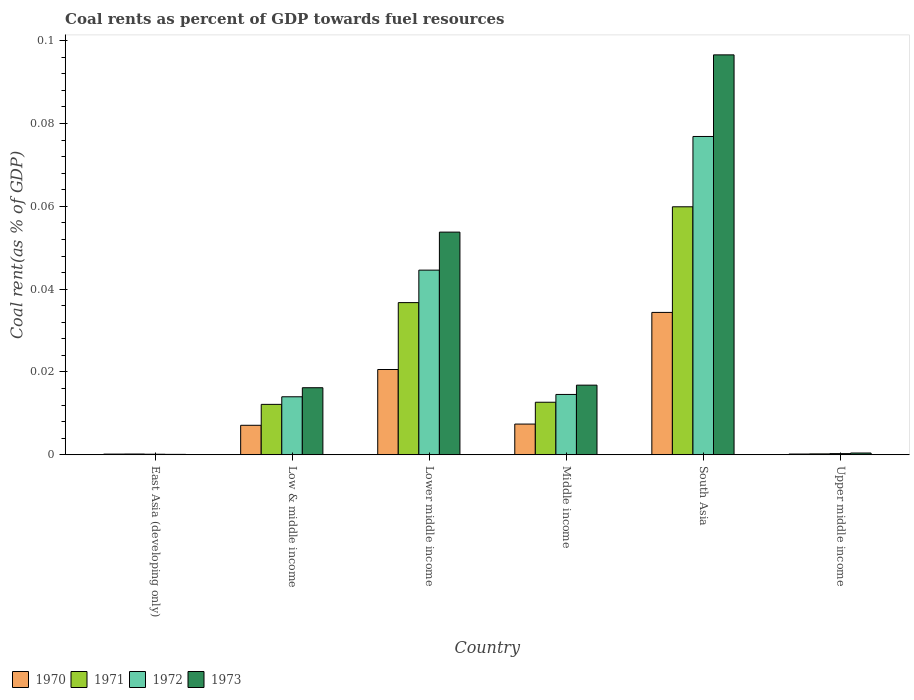How many groups of bars are there?
Provide a short and direct response. 6. Are the number of bars on each tick of the X-axis equal?
Your answer should be very brief. Yes. How many bars are there on the 6th tick from the left?
Your response must be concise. 4. What is the label of the 6th group of bars from the left?
Ensure brevity in your answer.  Upper middle income. What is the coal rent in 1972 in Middle income?
Keep it short and to the point. 0.01. Across all countries, what is the maximum coal rent in 1973?
Provide a short and direct response. 0.1. Across all countries, what is the minimum coal rent in 1970?
Provide a succinct answer. 0. In which country was the coal rent in 1972 minimum?
Your answer should be very brief. East Asia (developing only). What is the total coal rent in 1970 in the graph?
Provide a short and direct response. 0.07. What is the difference between the coal rent in 1973 in Low & middle income and that in Upper middle income?
Ensure brevity in your answer.  0.02. What is the difference between the coal rent in 1972 in Low & middle income and the coal rent in 1973 in Upper middle income?
Ensure brevity in your answer.  0.01. What is the average coal rent in 1971 per country?
Offer a very short reply. 0.02. What is the difference between the coal rent of/in 1970 and coal rent of/in 1971 in Middle income?
Give a very brief answer. -0.01. What is the ratio of the coal rent in 1973 in East Asia (developing only) to that in Lower middle income?
Provide a succinct answer. 0. Is the difference between the coal rent in 1970 in East Asia (developing only) and Upper middle income greater than the difference between the coal rent in 1971 in East Asia (developing only) and Upper middle income?
Make the answer very short. Yes. What is the difference between the highest and the second highest coal rent in 1973?
Make the answer very short. 0.08. What is the difference between the highest and the lowest coal rent in 1972?
Provide a succinct answer. 0.08. What does the 3rd bar from the left in Lower middle income represents?
Keep it short and to the point. 1972. What does the 3rd bar from the right in South Asia represents?
Offer a very short reply. 1971. Is it the case that in every country, the sum of the coal rent in 1972 and coal rent in 1971 is greater than the coal rent in 1970?
Keep it short and to the point. Yes. How many countries are there in the graph?
Your answer should be compact. 6. Are the values on the major ticks of Y-axis written in scientific E-notation?
Make the answer very short. No. Does the graph contain grids?
Keep it short and to the point. No. Where does the legend appear in the graph?
Offer a very short reply. Bottom left. How many legend labels are there?
Offer a very short reply. 4. How are the legend labels stacked?
Provide a short and direct response. Horizontal. What is the title of the graph?
Provide a short and direct response. Coal rents as percent of GDP towards fuel resources. Does "2004" appear as one of the legend labels in the graph?
Make the answer very short. No. What is the label or title of the X-axis?
Offer a very short reply. Country. What is the label or title of the Y-axis?
Your answer should be compact. Coal rent(as % of GDP). What is the Coal rent(as % of GDP) in 1970 in East Asia (developing only)?
Offer a terse response. 0. What is the Coal rent(as % of GDP) in 1971 in East Asia (developing only)?
Offer a very short reply. 0. What is the Coal rent(as % of GDP) of 1972 in East Asia (developing only)?
Keep it short and to the point. 0. What is the Coal rent(as % of GDP) of 1973 in East Asia (developing only)?
Your answer should be very brief. 0. What is the Coal rent(as % of GDP) of 1970 in Low & middle income?
Make the answer very short. 0.01. What is the Coal rent(as % of GDP) of 1971 in Low & middle income?
Make the answer very short. 0.01. What is the Coal rent(as % of GDP) of 1972 in Low & middle income?
Provide a short and direct response. 0.01. What is the Coal rent(as % of GDP) in 1973 in Low & middle income?
Offer a terse response. 0.02. What is the Coal rent(as % of GDP) of 1970 in Lower middle income?
Provide a succinct answer. 0.02. What is the Coal rent(as % of GDP) in 1971 in Lower middle income?
Give a very brief answer. 0.04. What is the Coal rent(as % of GDP) in 1972 in Lower middle income?
Give a very brief answer. 0.04. What is the Coal rent(as % of GDP) in 1973 in Lower middle income?
Provide a short and direct response. 0.05. What is the Coal rent(as % of GDP) of 1970 in Middle income?
Offer a terse response. 0.01. What is the Coal rent(as % of GDP) of 1971 in Middle income?
Offer a very short reply. 0.01. What is the Coal rent(as % of GDP) in 1972 in Middle income?
Make the answer very short. 0.01. What is the Coal rent(as % of GDP) of 1973 in Middle income?
Provide a succinct answer. 0.02. What is the Coal rent(as % of GDP) in 1970 in South Asia?
Offer a terse response. 0.03. What is the Coal rent(as % of GDP) of 1971 in South Asia?
Provide a succinct answer. 0.06. What is the Coal rent(as % of GDP) in 1972 in South Asia?
Your answer should be very brief. 0.08. What is the Coal rent(as % of GDP) in 1973 in South Asia?
Keep it short and to the point. 0.1. What is the Coal rent(as % of GDP) of 1970 in Upper middle income?
Your answer should be very brief. 0. What is the Coal rent(as % of GDP) of 1971 in Upper middle income?
Your response must be concise. 0. What is the Coal rent(as % of GDP) in 1972 in Upper middle income?
Provide a short and direct response. 0. What is the Coal rent(as % of GDP) in 1973 in Upper middle income?
Offer a terse response. 0. Across all countries, what is the maximum Coal rent(as % of GDP) of 1970?
Make the answer very short. 0.03. Across all countries, what is the maximum Coal rent(as % of GDP) of 1971?
Your answer should be compact. 0.06. Across all countries, what is the maximum Coal rent(as % of GDP) in 1972?
Provide a short and direct response. 0.08. Across all countries, what is the maximum Coal rent(as % of GDP) in 1973?
Keep it short and to the point. 0.1. Across all countries, what is the minimum Coal rent(as % of GDP) in 1970?
Provide a short and direct response. 0. Across all countries, what is the minimum Coal rent(as % of GDP) of 1971?
Your answer should be very brief. 0. Across all countries, what is the minimum Coal rent(as % of GDP) of 1972?
Your answer should be compact. 0. Across all countries, what is the minimum Coal rent(as % of GDP) in 1973?
Give a very brief answer. 0. What is the total Coal rent(as % of GDP) in 1970 in the graph?
Offer a terse response. 0.07. What is the total Coal rent(as % of GDP) in 1971 in the graph?
Your answer should be very brief. 0.12. What is the total Coal rent(as % of GDP) of 1972 in the graph?
Your answer should be compact. 0.15. What is the total Coal rent(as % of GDP) in 1973 in the graph?
Your answer should be very brief. 0.18. What is the difference between the Coal rent(as % of GDP) in 1970 in East Asia (developing only) and that in Low & middle income?
Your answer should be compact. -0.01. What is the difference between the Coal rent(as % of GDP) of 1971 in East Asia (developing only) and that in Low & middle income?
Keep it short and to the point. -0.01. What is the difference between the Coal rent(as % of GDP) in 1972 in East Asia (developing only) and that in Low & middle income?
Make the answer very short. -0.01. What is the difference between the Coal rent(as % of GDP) in 1973 in East Asia (developing only) and that in Low & middle income?
Provide a succinct answer. -0.02. What is the difference between the Coal rent(as % of GDP) of 1970 in East Asia (developing only) and that in Lower middle income?
Provide a short and direct response. -0.02. What is the difference between the Coal rent(as % of GDP) in 1971 in East Asia (developing only) and that in Lower middle income?
Provide a succinct answer. -0.04. What is the difference between the Coal rent(as % of GDP) in 1972 in East Asia (developing only) and that in Lower middle income?
Make the answer very short. -0.04. What is the difference between the Coal rent(as % of GDP) of 1973 in East Asia (developing only) and that in Lower middle income?
Keep it short and to the point. -0.05. What is the difference between the Coal rent(as % of GDP) in 1970 in East Asia (developing only) and that in Middle income?
Provide a short and direct response. -0.01. What is the difference between the Coal rent(as % of GDP) of 1971 in East Asia (developing only) and that in Middle income?
Keep it short and to the point. -0.01. What is the difference between the Coal rent(as % of GDP) of 1972 in East Asia (developing only) and that in Middle income?
Your response must be concise. -0.01. What is the difference between the Coal rent(as % of GDP) in 1973 in East Asia (developing only) and that in Middle income?
Keep it short and to the point. -0.02. What is the difference between the Coal rent(as % of GDP) in 1970 in East Asia (developing only) and that in South Asia?
Your response must be concise. -0.03. What is the difference between the Coal rent(as % of GDP) of 1971 in East Asia (developing only) and that in South Asia?
Provide a short and direct response. -0.06. What is the difference between the Coal rent(as % of GDP) in 1972 in East Asia (developing only) and that in South Asia?
Keep it short and to the point. -0.08. What is the difference between the Coal rent(as % of GDP) in 1973 in East Asia (developing only) and that in South Asia?
Ensure brevity in your answer.  -0.1. What is the difference between the Coal rent(as % of GDP) in 1971 in East Asia (developing only) and that in Upper middle income?
Keep it short and to the point. -0. What is the difference between the Coal rent(as % of GDP) in 1972 in East Asia (developing only) and that in Upper middle income?
Keep it short and to the point. -0. What is the difference between the Coal rent(as % of GDP) in 1973 in East Asia (developing only) and that in Upper middle income?
Make the answer very short. -0. What is the difference between the Coal rent(as % of GDP) of 1970 in Low & middle income and that in Lower middle income?
Your response must be concise. -0.01. What is the difference between the Coal rent(as % of GDP) in 1971 in Low & middle income and that in Lower middle income?
Make the answer very short. -0.02. What is the difference between the Coal rent(as % of GDP) of 1972 in Low & middle income and that in Lower middle income?
Make the answer very short. -0.03. What is the difference between the Coal rent(as % of GDP) in 1973 in Low & middle income and that in Lower middle income?
Offer a terse response. -0.04. What is the difference between the Coal rent(as % of GDP) in 1970 in Low & middle income and that in Middle income?
Provide a short and direct response. -0. What is the difference between the Coal rent(as % of GDP) in 1971 in Low & middle income and that in Middle income?
Your response must be concise. -0. What is the difference between the Coal rent(as % of GDP) in 1972 in Low & middle income and that in Middle income?
Make the answer very short. -0. What is the difference between the Coal rent(as % of GDP) in 1973 in Low & middle income and that in Middle income?
Give a very brief answer. -0. What is the difference between the Coal rent(as % of GDP) of 1970 in Low & middle income and that in South Asia?
Your response must be concise. -0.03. What is the difference between the Coal rent(as % of GDP) of 1971 in Low & middle income and that in South Asia?
Provide a short and direct response. -0.05. What is the difference between the Coal rent(as % of GDP) in 1972 in Low & middle income and that in South Asia?
Provide a short and direct response. -0.06. What is the difference between the Coal rent(as % of GDP) of 1973 in Low & middle income and that in South Asia?
Ensure brevity in your answer.  -0.08. What is the difference between the Coal rent(as % of GDP) of 1970 in Low & middle income and that in Upper middle income?
Provide a short and direct response. 0.01. What is the difference between the Coal rent(as % of GDP) of 1971 in Low & middle income and that in Upper middle income?
Keep it short and to the point. 0.01. What is the difference between the Coal rent(as % of GDP) in 1972 in Low & middle income and that in Upper middle income?
Provide a short and direct response. 0.01. What is the difference between the Coal rent(as % of GDP) of 1973 in Low & middle income and that in Upper middle income?
Your answer should be compact. 0.02. What is the difference between the Coal rent(as % of GDP) in 1970 in Lower middle income and that in Middle income?
Make the answer very short. 0.01. What is the difference between the Coal rent(as % of GDP) of 1971 in Lower middle income and that in Middle income?
Provide a succinct answer. 0.02. What is the difference between the Coal rent(as % of GDP) of 1973 in Lower middle income and that in Middle income?
Your answer should be very brief. 0.04. What is the difference between the Coal rent(as % of GDP) in 1970 in Lower middle income and that in South Asia?
Provide a short and direct response. -0.01. What is the difference between the Coal rent(as % of GDP) of 1971 in Lower middle income and that in South Asia?
Provide a short and direct response. -0.02. What is the difference between the Coal rent(as % of GDP) in 1972 in Lower middle income and that in South Asia?
Offer a very short reply. -0.03. What is the difference between the Coal rent(as % of GDP) of 1973 in Lower middle income and that in South Asia?
Give a very brief answer. -0.04. What is the difference between the Coal rent(as % of GDP) of 1970 in Lower middle income and that in Upper middle income?
Give a very brief answer. 0.02. What is the difference between the Coal rent(as % of GDP) in 1971 in Lower middle income and that in Upper middle income?
Provide a short and direct response. 0.04. What is the difference between the Coal rent(as % of GDP) in 1972 in Lower middle income and that in Upper middle income?
Offer a terse response. 0.04. What is the difference between the Coal rent(as % of GDP) in 1973 in Lower middle income and that in Upper middle income?
Provide a succinct answer. 0.05. What is the difference between the Coal rent(as % of GDP) in 1970 in Middle income and that in South Asia?
Make the answer very short. -0.03. What is the difference between the Coal rent(as % of GDP) of 1971 in Middle income and that in South Asia?
Ensure brevity in your answer.  -0.05. What is the difference between the Coal rent(as % of GDP) in 1972 in Middle income and that in South Asia?
Provide a succinct answer. -0.06. What is the difference between the Coal rent(as % of GDP) of 1973 in Middle income and that in South Asia?
Give a very brief answer. -0.08. What is the difference between the Coal rent(as % of GDP) of 1970 in Middle income and that in Upper middle income?
Keep it short and to the point. 0.01. What is the difference between the Coal rent(as % of GDP) in 1971 in Middle income and that in Upper middle income?
Your answer should be very brief. 0.01. What is the difference between the Coal rent(as % of GDP) of 1972 in Middle income and that in Upper middle income?
Your answer should be compact. 0.01. What is the difference between the Coal rent(as % of GDP) in 1973 in Middle income and that in Upper middle income?
Offer a very short reply. 0.02. What is the difference between the Coal rent(as % of GDP) of 1970 in South Asia and that in Upper middle income?
Keep it short and to the point. 0.03. What is the difference between the Coal rent(as % of GDP) of 1971 in South Asia and that in Upper middle income?
Your response must be concise. 0.06. What is the difference between the Coal rent(as % of GDP) in 1972 in South Asia and that in Upper middle income?
Keep it short and to the point. 0.08. What is the difference between the Coal rent(as % of GDP) in 1973 in South Asia and that in Upper middle income?
Ensure brevity in your answer.  0.1. What is the difference between the Coal rent(as % of GDP) of 1970 in East Asia (developing only) and the Coal rent(as % of GDP) of 1971 in Low & middle income?
Provide a succinct answer. -0.01. What is the difference between the Coal rent(as % of GDP) of 1970 in East Asia (developing only) and the Coal rent(as % of GDP) of 1972 in Low & middle income?
Offer a terse response. -0.01. What is the difference between the Coal rent(as % of GDP) in 1970 in East Asia (developing only) and the Coal rent(as % of GDP) in 1973 in Low & middle income?
Give a very brief answer. -0.02. What is the difference between the Coal rent(as % of GDP) of 1971 in East Asia (developing only) and the Coal rent(as % of GDP) of 1972 in Low & middle income?
Offer a terse response. -0.01. What is the difference between the Coal rent(as % of GDP) in 1971 in East Asia (developing only) and the Coal rent(as % of GDP) in 1973 in Low & middle income?
Your answer should be compact. -0.02. What is the difference between the Coal rent(as % of GDP) of 1972 in East Asia (developing only) and the Coal rent(as % of GDP) of 1973 in Low & middle income?
Offer a very short reply. -0.02. What is the difference between the Coal rent(as % of GDP) of 1970 in East Asia (developing only) and the Coal rent(as % of GDP) of 1971 in Lower middle income?
Keep it short and to the point. -0.04. What is the difference between the Coal rent(as % of GDP) in 1970 in East Asia (developing only) and the Coal rent(as % of GDP) in 1972 in Lower middle income?
Offer a terse response. -0.04. What is the difference between the Coal rent(as % of GDP) of 1970 in East Asia (developing only) and the Coal rent(as % of GDP) of 1973 in Lower middle income?
Make the answer very short. -0.05. What is the difference between the Coal rent(as % of GDP) in 1971 in East Asia (developing only) and the Coal rent(as % of GDP) in 1972 in Lower middle income?
Offer a very short reply. -0.04. What is the difference between the Coal rent(as % of GDP) in 1971 in East Asia (developing only) and the Coal rent(as % of GDP) in 1973 in Lower middle income?
Offer a very short reply. -0.05. What is the difference between the Coal rent(as % of GDP) of 1972 in East Asia (developing only) and the Coal rent(as % of GDP) of 1973 in Lower middle income?
Provide a succinct answer. -0.05. What is the difference between the Coal rent(as % of GDP) in 1970 in East Asia (developing only) and the Coal rent(as % of GDP) in 1971 in Middle income?
Keep it short and to the point. -0.01. What is the difference between the Coal rent(as % of GDP) in 1970 in East Asia (developing only) and the Coal rent(as % of GDP) in 1972 in Middle income?
Offer a very short reply. -0.01. What is the difference between the Coal rent(as % of GDP) of 1970 in East Asia (developing only) and the Coal rent(as % of GDP) of 1973 in Middle income?
Offer a terse response. -0.02. What is the difference between the Coal rent(as % of GDP) in 1971 in East Asia (developing only) and the Coal rent(as % of GDP) in 1972 in Middle income?
Make the answer very short. -0.01. What is the difference between the Coal rent(as % of GDP) in 1971 in East Asia (developing only) and the Coal rent(as % of GDP) in 1973 in Middle income?
Keep it short and to the point. -0.02. What is the difference between the Coal rent(as % of GDP) of 1972 in East Asia (developing only) and the Coal rent(as % of GDP) of 1973 in Middle income?
Your answer should be compact. -0.02. What is the difference between the Coal rent(as % of GDP) of 1970 in East Asia (developing only) and the Coal rent(as % of GDP) of 1971 in South Asia?
Offer a very short reply. -0.06. What is the difference between the Coal rent(as % of GDP) in 1970 in East Asia (developing only) and the Coal rent(as % of GDP) in 1972 in South Asia?
Provide a short and direct response. -0.08. What is the difference between the Coal rent(as % of GDP) of 1970 in East Asia (developing only) and the Coal rent(as % of GDP) of 1973 in South Asia?
Your response must be concise. -0.1. What is the difference between the Coal rent(as % of GDP) in 1971 in East Asia (developing only) and the Coal rent(as % of GDP) in 1972 in South Asia?
Make the answer very short. -0.08. What is the difference between the Coal rent(as % of GDP) of 1971 in East Asia (developing only) and the Coal rent(as % of GDP) of 1973 in South Asia?
Make the answer very short. -0.1. What is the difference between the Coal rent(as % of GDP) of 1972 in East Asia (developing only) and the Coal rent(as % of GDP) of 1973 in South Asia?
Provide a succinct answer. -0.1. What is the difference between the Coal rent(as % of GDP) in 1970 in East Asia (developing only) and the Coal rent(as % of GDP) in 1971 in Upper middle income?
Your answer should be very brief. -0. What is the difference between the Coal rent(as % of GDP) in 1970 in East Asia (developing only) and the Coal rent(as % of GDP) in 1972 in Upper middle income?
Your response must be concise. -0. What is the difference between the Coal rent(as % of GDP) in 1970 in East Asia (developing only) and the Coal rent(as % of GDP) in 1973 in Upper middle income?
Your answer should be very brief. -0. What is the difference between the Coal rent(as % of GDP) of 1971 in East Asia (developing only) and the Coal rent(as % of GDP) of 1972 in Upper middle income?
Your response must be concise. -0. What is the difference between the Coal rent(as % of GDP) of 1971 in East Asia (developing only) and the Coal rent(as % of GDP) of 1973 in Upper middle income?
Your response must be concise. -0. What is the difference between the Coal rent(as % of GDP) in 1972 in East Asia (developing only) and the Coal rent(as % of GDP) in 1973 in Upper middle income?
Offer a very short reply. -0. What is the difference between the Coal rent(as % of GDP) in 1970 in Low & middle income and the Coal rent(as % of GDP) in 1971 in Lower middle income?
Offer a terse response. -0.03. What is the difference between the Coal rent(as % of GDP) in 1970 in Low & middle income and the Coal rent(as % of GDP) in 1972 in Lower middle income?
Offer a very short reply. -0.04. What is the difference between the Coal rent(as % of GDP) of 1970 in Low & middle income and the Coal rent(as % of GDP) of 1973 in Lower middle income?
Keep it short and to the point. -0.05. What is the difference between the Coal rent(as % of GDP) of 1971 in Low & middle income and the Coal rent(as % of GDP) of 1972 in Lower middle income?
Your answer should be very brief. -0.03. What is the difference between the Coal rent(as % of GDP) of 1971 in Low & middle income and the Coal rent(as % of GDP) of 1973 in Lower middle income?
Your answer should be very brief. -0.04. What is the difference between the Coal rent(as % of GDP) in 1972 in Low & middle income and the Coal rent(as % of GDP) in 1973 in Lower middle income?
Provide a succinct answer. -0.04. What is the difference between the Coal rent(as % of GDP) of 1970 in Low & middle income and the Coal rent(as % of GDP) of 1971 in Middle income?
Your answer should be very brief. -0.01. What is the difference between the Coal rent(as % of GDP) of 1970 in Low & middle income and the Coal rent(as % of GDP) of 1972 in Middle income?
Offer a terse response. -0.01. What is the difference between the Coal rent(as % of GDP) of 1970 in Low & middle income and the Coal rent(as % of GDP) of 1973 in Middle income?
Provide a succinct answer. -0.01. What is the difference between the Coal rent(as % of GDP) of 1971 in Low & middle income and the Coal rent(as % of GDP) of 1972 in Middle income?
Your response must be concise. -0. What is the difference between the Coal rent(as % of GDP) in 1971 in Low & middle income and the Coal rent(as % of GDP) in 1973 in Middle income?
Make the answer very short. -0. What is the difference between the Coal rent(as % of GDP) in 1972 in Low & middle income and the Coal rent(as % of GDP) in 1973 in Middle income?
Your answer should be very brief. -0. What is the difference between the Coal rent(as % of GDP) of 1970 in Low & middle income and the Coal rent(as % of GDP) of 1971 in South Asia?
Offer a very short reply. -0.05. What is the difference between the Coal rent(as % of GDP) in 1970 in Low & middle income and the Coal rent(as % of GDP) in 1972 in South Asia?
Keep it short and to the point. -0.07. What is the difference between the Coal rent(as % of GDP) in 1970 in Low & middle income and the Coal rent(as % of GDP) in 1973 in South Asia?
Ensure brevity in your answer.  -0.09. What is the difference between the Coal rent(as % of GDP) of 1971 in Low & middle income and the Coal rent(as % of GDP) of 1972 in South Asia?
Your response must be concise. -0.06. What is the difference between the Coal rent(as % of GDP) of 1971 in Low & middle income and the Coal rent(as % of GDP) of 1973 in South Asia?
Offer a very short reply. -0.08. What is the difference between the Coal rent(as % of GDP) in 1972 in Low & middle income and the Coal rent(as % of GDP) in 1973 in South Asia?
Provide a succinct answer. -0.08. What is the difference between the Coal rent(as % of GDP) of 1970 in Low & middle income and the Coal rent(as % of GDP) of 1971 in Upper middle income?
Offer a terse response. 0.01. What is the difference between the Coal rent(as % of GDP) in 1970 in Low & middle income and the Coal rent(as % of GDP) in 1972 in Upper middle income?
Your answer should be very brief. 0.01. What is the difference between the Coal rent(as % of GDP) in 1970 in Low & middle income and the Coal rent(as % of GDP) in 1973 in Upper middle income?
Your answer should be compact. 0.01. What is the difference between the Coal rent(as % of GDP) in 1971 in Low & middle income and the Coal rent(as % of GDP) in 1972 in Upper middle income?
Ensure brevity in your answer.  0.01. What is the difference between the Coal rent(as % of GDP) in 1971 in Low & middle income and the Coal rent(as % of GDP) in 1973 in Upper middle income?
Your answer should be compact. 0.01. What is the difference between the Coal rent(as % of GDP) of 1972 in Low & middle income and the Coal rent(as % of GDP) of 1973 in Upper middle income?
Keep it short and to the point. 0.01. What is the difference between the Coal rent(as % of GDP) in 1970 in Lower middle income and the Coal rent(as % of GDP) in 1971 in Middle income?
Offer a very short reply. 0.01. What is the difference between the Coal rent(as % of GDP) of 1970 in Lower middle income and the Coal rent(as % of GDP) of 1972 in Middle income?
Give a very brief answer. 0.01. What is the difference between the Coal rent(as % of GDP) in 1970 in Lower middle income and the Coal rent(as % of GDP) in 1973 in Middle income?
Provide a succinct answer. 0. What is the difference between the Coal rent(as % of GDP) in 1971 in Lower middle income and the Coal rent(as % of GDP) in 1972 in Middle income?
Give a very brief answer. 0.02. What is the difference between the Coal rent(as % of GDP) in 1971 in Lower middle income and the Coal rent(as % of GDP) in 1973 in Middle income?
Provide a succinct answer. 0.02. What is the difference between the Coal rent(as % of GDP) in 1972 in Lower middle income and the Coal rent(as % of GDP) in 1973 in Middle income?
Provide a succinct answer. 0.03. What is the difference between the Coal rent(as % of GDP) of 1970 in Lower middle income and the Coal rent(as % of GDP) of 1971 in South Asia?
Provide a short and direct response. -0.04. What is the difference between the Coal rent(as % of GDP) in 1970 in Lower middle income and the Coal rent(as % of GDP) in 1972 in South Asia?
Your response must be concise. -0.06. What is the difference between the Coal rent(as % of GDP) of 1970 in Lower middle income and the Coal rent(as % of GDP) of 1973 in South Asia?
Make the answer very short. -0.08. What is the difference between the Coal rent(as % of GDP) in 1971 in Lower middle income and the Coal rent(as % of GDP) in 1972 in South Asia?
Ensure brevity in your answer.  -0.04. What is the difference between the Coal rent(as % of GDP) in 1971 in Lower middle income and the Coal rent(as % of GDP) in 1973 in South Asia?
Your response must be concise. -0.06. What is the difference between the Coal rent(as % of GDP) in 1972 in Lower middle income and the Coal rent(as % of GDP) in 1973 in South Asia?
Provide a short and direct response. -0.05. What is the difference between the Coal rent(as % of GDP) in 1970 in Lower middle income and the Coal rent(as % of GDP) in 1971 in Upper middle income?
Offer a very short reply. 0.02. What is the difference between the Coal rent(as % of GDP) of 1970 in Lower middle income and the Coal rent(as % of GDP) of 1972 in Upper middle income?
Your answer should be compact. 0.02. What is the difference between the Coal rent(as % of GDP) of 1970 in Lower middle income and the Coal rent(as % of GDP) of 1973 in Upper middle income?
Ensure brevity in your answer.  0.02. What is the difference between the Coal rent(as % of GDP) of 1971 in Lower middle income and the Coal rent(as % of GDP) of 1972 in Upper middle income?
Offer a very short reply. 0.04. What is the difference between the Coal rent(as % of GDP) in 1971 in Lower middle income and the Coal rent(as % of GDP) in 1973 in Upper middle income?
Keep it short and to the point. 0.04. What is the difference between the Coal rent(as % of GDP) in 1972 in Lower middle income and the Coal rent(as % of GDP) in 1973 in Upper middle income?
Your response must be concise. 0.04. What is the difference between the Coal rent(as % of GDP) of 1970 in Middle income and the Coal rent(as % of GDP) of 1971 in South Asia?
Give a very brief answer. -0.05. What is the difference between the Coal rent(as % of GDP) in 1970 in Middle income and the Coal rent(as % of GDP) in 1972 in South Asia?
Keep it short and to the point. -0.07. What is the difference between the Coal rent(as % of GDP) of 1970 in Middle income and the Coal rent(as % of GDP) of 1973 in South Asia?
Make the answer very short. -0.09. What is the difference between the Coal rent(as % of GDP) of 1971 in Middle income and the Coal rent(as % of GDP) of 1972 in South Asia?
Make the answer very short. -0.06. What is the difference between the Coal rent(as % of GDP) in 1971 in Middle income and the Coal rent(as % of GDP) in 1973 in South Asia?
Your response must be concise. -0.08. What is the difference between the Coal rent(as % of GDP) of 1972 in Middle income and the Coal rent(as % of GDP) of 1973 in South Asia?
Give a very brief answer. -0.08. What is the difference between the Coal rent(as % of GDP) of 1970 in Middle income and the Coal rent(as % of GDP) of 1971 in Upper middle income?
Keep it short and to the point. 0.01. What is the difference between the Coal rent(as % of GDP) of 1970 in Middle income and the Coal rent(as % of GDP) of 1972 in Upper middle income?
Make the answer very short. 0.01. What is the difference between the Coal rent(as % of GDP) in 1970 in Middle income and the Coal rent(as % of GDP) in 1973 in Upper middle income?
Provide a succinct answer. 0.01. What is the difference between the Coal rent(as % of GDP) of 1971 in Middle income and the Coal rent(as % of GDP) of 1972 in Upper middle income?
Make the answer very short. 0.01. What is the difference between the Coal rent(as % of GDP) of 1971 in Middle income and the Coal rent(as % of GDP) of 1973 in Upper middle income?
Ensure brevity in your answer.  0.01. What is the difference between the Coal rent(as % of GDP) of 1972 in Middle income and the Coal rent(as % of GDP) of 1973 in Upper middle income?
Your answer should be compact. 0.01. What is the difference between the Coal rent(as % of GDP) of 1970 in South Asia and the Coal rent(as % of GDP) of 1971 in Upper middle income?
Provide a short and direct response. 0.03. What is the difference between the Coal rent(as % of GDP) in 1970 in South Asia and the Coal rent(as % of GDP) in 1972 in Upper middle income?
Your response must be concise. 0.03. What is the difference between the Coal rent(as % of GDP) of 1970 in South Asia and the Coal rent(as % of GDP) of 1973 in Upper middle income?
Keep it short and to the point. 0.03. What is the difference between the Coal rent(as % of GDP) of 1971 in South Asia and the Coal rent(as % of GDP) of 1972 in Upper middle income?
Provide a succinct answer. 0.06. What is the difference between the Coal rent(as % of GDP) of 1971 in South Asia and the Coal rent(as % of GDP) of 1973 in Upper middle income?
Offer a very short reply. 0.06. What is the difference between the Coal rent(as % of GDP) in 1972 in South Asia and the Coal rent(as % of GDP) in 1973 in Upper middle income?
Keep it short and to the point. 0.08. What is the average Coal rent(as % of GDP) in 1970 per country?
Your answer should be very brief. 0.01. What is the average Coal rent(as % of GDP) in 1971 per country?
Provide a short and direct response. 0.02. What is the average Coal rent(as % of GDP) in 1972 per country?
Ensure brevity in your answer.  0.03. What is the average Coal rent(as % of GDP) of 1973 per country?
Keep it short and to the point. 0.03. What is the difference between the Coal rent(as % of GDP) in 1970 and Coal rent(as % of GDP) in 1971 in East Asia (developing only)?
Offer a terse response. -0. What is the difference between the Coal rent(as % of GDP) of 1970 and Coal rent(as % of GDP) of 1971 in Low & middle income?
Your response must be concise. -0.01. What is the difference between the Coal rent(as % of GDP) in 1970 and Coal rent(as % of GDP) in 1972 in Low & middle income?
Make the answer very short. -0.01. What is the difference between the Coal rent(as % of GDP) of 1970 and Coal rent(as % of GDP) of 1973 in Low & middle income?
Your answer should be compact. -0.01. What is the difference between the Coal rent(as % of GDP) of 1971 and Coal rent(as % of GDP) of 1972 in Low & middle income?
Provide a succinct answer. -0. What is the difference between the Coal rent(as % of GDP) in 1971 and Coal rent(as % of GDP) in 1973 in Low & middle income?
Your answer should be compact. -0. What is the difference between the Coal rent(as % of GDP) of 1972 and Coal rent(as % of GDP) of 1973 in Low & middle income?
Your answer should be compact. -0. What is the difference between the Coal rent(as % of GDP) in 1970 and Coal rent(as % of GDP) in 1971 in Lower middle income?
Offer a very short reply. -0.02. What is the difference between the Coal rent(as % of GDP) in 1970 and Coal rent(as % of GDP) in 1972 in Lower middle income?
Provide a short and direct response. -0.02. What is the difference between the Coal rent(as % of GDP) in 1970 and Coal rent(as % of GDP) in 1973 in Lower middle income?
Ensure brevity in your answer.  -0.03. What is the difference between the Coal rent(as % of GDP) of 1971 and Coal rent(as % of GDP) of 1972 in Lower middle income?
Make the answer very short. -0.01. What is the difference between the Coal rent(as % of GDP) of 1971 and Coal rent(as % of GDP) of 1973 in Lower middle income?
Offer a terse response. -0.02. What is the difference between the Coal rent(as % of GDP) in 1972 and Coal rent(as % of GDP) in 1973 in Lower middle income?
Provide a succinct answer. -0.01. What is the difference between the Coal rent(as % of GDP) of 1970 and Coal rent(as % of GDP) of 1971 in Middle income?
Give a very brief answer. -0.01. What is the difference between the Coal rent(as % of GDP) of 1970 and Coal rent(as % of GDP) of 1972 in Middle income?
Your response must be concise. -0.01. What is the difference between the Coal rent(as % of GDP) in 1970 and Coal rent(as % of GDP) in 1973 in Middle income?
Ensure brevity in your answer.  -0.01. What is the difference between the Coal rent(as % of GDP) in 1971 and Coal rent(as % of GDP) in 1972 in Middle income?
Your answer should be compact. -0. What is the difference between the Coal rent(as % of GDP) of 1971 and Coal rent(as % of GDP) of 1973 in Middle income?
Provide a succinct answer. -0. What is the difference between the Coal rent(as % of GDP) of 1972 and Coal rent(as % of GDP) of 1973 in Middle income?
Keep it short and to the point. -0. What is the difference between the Coal rent(as % of GDP) of 1970 and Coal rent(as % of GDP) of 1971 in South Asia?
Provide a succinct answer. -0.03. What is the difference between the Coal rent(as % of GDP) in 1970 and Coal rent(as % of GDP) in 1972 in South Asia?
Ensure brevity in your answer.  -0.04. What is the difference between the Coal rent(as % of GDP) in 1970 and Coal rent(as % of GDP) in 1973 in South Asia?
Provide a short and direct response. -0.06. What is the difference between the Coal rent(as % of GDP) of 1971 and Coal rent(as % of GDP) of 1972 in South Asia?
Give a very brief answer. -0.02. What is the difference between the Coal rent(as % of GDP) of 1971 and Coal rent(as % of GDP) of 1973 in South Asia?
Provide a short and direct response. -0.04. What is the difference between the Coal rent(as % of GDP) of 1972 and Coal rent(as % of GDP) of 1973 in South Asia?
Keep it short and to the point. -0.02. What is the difference between the Coal rent(as % of GDP) of 1970 and Coal rent(as % of GDP) of 1971 in Upper middle income?
Provide a succinct answer. -0. What is the difference between the Coal rent(as % of GDP) of 1970 and Coal rent(as % of GDP) of 1972 in Upper middle income?
Provide a succinct answer. -0. What is the difference between the Coal rent(as % of GDP) of 1970 and Coal rent(as % of GDP) of 1973 in Upper middle income?
Offer a very short reply. -0. What is the difference between the Coal rent(as % of GDP) in 1971 and Coal rent(as % of GDP) in 1972 in Upper middle income?
Offer a very short reply. -0. What is the difference between the Coal rent(as % of GDP) of 1971 and Coal rent(as % of GDP) of 1973 in Upper middle income?
Give a very brief answer. -0. What is the difference between the Coal rent(as % of GDP) of 1972 and Coal rent(as % of GDP) of 1973 in Upper middle income?
Keep it short and to the point. -0. What is the ratio of the Coal rent(as % of GDP) of 1970 in East Asia (developing only) to that in Low & middle income?
Ensure brevity in your answer.  0.02. What is the ratio of the Coal rent(as % of GDP) of 1971 in East Asia (developing only) to that in Low & middle income?
Offer a terse response. 0.02. What is the ratio of the Coal rent(as % of GDP) of 1972 in East Asia (developing only) to that in Low & middle income?
Your answer should be compact. 0.01. What is the ratio of the Coal rent(as % of GDP) in 1973 in East Asia (developing only) to that in Low & middle income?
Ensure brevity in your answer.  0.01. What is the ratio of the Coal rent(as % of GDP) in 1970 in East Asia (developing only) to that in Lower middle income?
Your response must be concise. 0.01. What is the ratio of the Coal rent(as % of GDP) of 1971 in East Asia (developing only) to that in Lower middle income?
Your answer should be very brief. 0.01. What is the ratio of the Coal rent(as % of GDP) in 1972 in East Asia (developing only) to that in Lower middle income?
Provide a short and direct response. 0. What is the ratio of the Coal rent(as % of GDP) in 1973 in East Asia (developing only) to that in Lower middle income?
Your response must be concise. 0. What is the ratio of the Coal rent(as % of GDP) in 1970 in East Asia (developing only) to that in Middle income?
Provide a short and direct response. 0.02. What is the ratio of the Coal rent(as % of GDP) in 1971 in East Asia (developing only) to that in Middle income?
Ensure brevity in your answer.  0.01. What is the ratio of the Coal rent(as % of GDP) in 1972 in East Asia (developing only) to that in Middle income?
Your answer should be compact. 0.01. What is the ratio of the Coal rent(as % of GDP) in 1973 in East Asia (developing only) to that in Middle income?
Offer a terse response. 0.01. What is the ratio of the Coal rent(as % of GDP) of 1970 in East Asia (developing only) to that in South Asia?
Your answer should be very brief. 0. What is the ratio of the Coal rent(as % of GDP) in 1971 in East Asia (developing only) to that in South Asia?
Give a very brief answer. 0. What is the ratio of the Coal rent(as % of GDP) in 1972 in East Asia (developing only) to that in South Asia?
Provide a short and direct response. 0. What is the ratio of the Coal rent(as % of GDP) in 1973 in East Asia (developing only) to that in South Asia?
Offer a very short reply. 0. What is the ratio of the Coal rent(as % of GDP) of 1970 in East Asia (developing only) to that in Upper middle income?
Provide a short and direct response. 0.91. What is the ratio of the Coal rent(as % of GDP) in 1971 in East Asia (developing only) to that in Upper middle income?
Your answer should be compact. 0.86. What is the ratio of the Coal rent(as % of GDP) of 1972 in East Asia (developing only) to that in Upper middle income?
Your response must be concise. 0.48. What is the ratio of the Coal rent(as % of GDP) in 1973 in East Asia (developing only) to that in Upper middle income?
Ensure brevity in your answer.  0.24. What is the ratio of the Coal rent(as % of GDP) in 1970 in Low & middle income to that in Lower middle income?
Your response must be concise. 0.35. What is the ratio of the Coal rent(as % of GDP) of 1971 in Low & middle income to that in Lower middle income?
Give a very brief answer. 0.33. What is the ratio of the Coal rent(as % of GDP) of 1972 in Low & middle income to that in Lower middle income?
Your answer should be very brief. 0.31. What is the ratio of the Coal rent(as % of GDP) in 1973 in Low & middle income to that in Lower middle income?
Offer a terse response. 0.3. What is the ratio of the Coal rent(as % of GDP) of 1970 in Low & middle income to that in Middle income?
Give a very brief answer. 0.96. What is the ratio of the Coal rent(as % of GDP) in 1971 in Low & middle income to that in Middle income?
Ensure brevity in your answer.  0.96. What is the ratio of the Coal rent(as % of GDP) of 1972 in Low & middle income to that in Middle income?
Your answer should be compact. 0.96. What is the ratio of the Coal rent(as % of GDP) in 1973 in Low & middle income to that in Middle income?
Offer a terse response. 0.96. What is the ratio of the Coal rent(as % of GDP) in 1970 in Low & middle income to that in South Asia?
Your answer should be very brief. 0.21. What is the ratio of the Coal rent(as % of GDP) of 1971 in Low & middle income to that in South Asia?
Give a very brief answer. 0.2. What is the ratio of the Coal rent(as % of GDP) of 1972 in Low & middle income to that in South Asia?
Offer a very short reply. 0.18. What is the ratio of the Coal rent(as % of GDP) in 1973 in Low & middle income to that in South Asia?
Your answer should be very brief. 0.17. What is the ratio of the Coal rent(as % of GDP) in 1970 in Low & middle income to that in Upper middle income?
Your response must be concise. 38.77. What is the ratio of the Coal rent(as % of GDP) in 1971 in Low & middle income to that in Upper middle income?
Keep it short and to the point. 55.66. What is the ratio of the Coal rent(as % of GDP) of 1972 in Low & middle income to that in Upper middle income?
Your response must be concise. 49.28. What is the ratio of the Coal rent(as % of GDP) of 1973 in Low & middle income to that in Upper middle income?
Ensure brevity in your answer.  37.59. What is the ratio of the Coal rent(as % of GDP) in 1970 in Lower middle income to that in Middle income?
Your answer should be compact. 2.78. What is the ratio of the Coal rent(as % of GDP) in 1971 in Lower middle income to that in Middle income?
Provide a short and direct response. 2.9. What is the ratio of the Coal rent(as % of GDP) in 1972 in Lower middle income to that in Middle income?
Offer a very short reply. 3.06. What is the ratio of the Coal rent(as % of GDP) in 1973 in Lower middle income to that in Middle income?
Your response must be concise. 3.2. What is the ratio of the Coal rent(as % of GDP) in 1970 in Lower middle income to that in South Asia?
Provide a succinct answer. 0.6. What is the ratio of the Coal rent(as % of GDP) in 1971 in Lower middle income to that in South Asia?
Ensure brevity in your answer.  0.61. What is the ratio of the Coal rent(as % of GDP) in 1972 in Lower middle income to that in South Asia?
Your answer should be very brief. 0.58. What is the ratio of the Coal rent(as % of GDP) in 1973 in Lower middle income to that in South Asia?
Offer a very short reply. 0.56. What is the ratio of the Coal rent(as % of GDP) of 1970 in Lower middle income to that in Upper middle income?
Provide a succinct answer. 112.03. What is the ratio of the Coal rent(as % of GDP) of 1971 in Lower middle income to that in Upper middle income?
Offer a terse response. 167.98. What is the ratio of the Coal rent(as % of GDP) of 1972 in Lower middle income to that in Upper middle income?
Your response must be concise. 156.82. What is the ratio of the Coal rent(as % of GDP) in 1973 in Lower middle income to that in Upper middle income?
Your answer should be compact. 124.82. What is the ratio of the Coal rent(as % of GDP) in 1970 in Middle income to that in South Asia?
Make the answer very short. 0.22. What is the ratio of the Coal rent(as % of GDP) in 1971 in Middle income to that in South Asia?
Offer a very short reply. 0.21. What is the ratio of the Coal rent(as % of GDP) in 1972 in Middle income to that in South Asia?
Your answer should be compact. 0.19. What is the ratio of the Coal rent(as % of GDP) in 1973 in Middle income to that in South Asia?
Give a very brief answer. 0.17. What is the ratio of the Coal rent(as % of GDP) in 1970 in Middle income to that in Upper middle income?
Give a very brief answer. 40.36. What is the ratio of the Coal rent(as % of GDP) in 1971 in Middle income to that in Upper middle income?
Your answer should be very brief. 58.01. What is the ratio of the Coal rent(as % of GDP) in 1972 in Middle income to that in Upper middle income?
Provide a succinct answer. 51.25. What is the ratio of the Coal rent(as % of GDP) in 1973 in Middle income to that in Upper middle income?
Your answer should be compact. 39.04. What is the ratio of the Coal rent(as % of GDP) in 1970 in South Asia to that in Upper middle income?
Keep it short and to the point. 187.05. What is the ratio of the Coal rent(as % of GDP) in 1971 in South Asia to that in Upper middle income?
Provide a succinct answer. 273.74. What is the ratio of the Coal rent(as % of GDP) in 1972 in South Asia to that in Upper middle income?
Your response must be concise. 270.32. What is the ratio of the Coal rent(as % of GDP) in 1973 in South Asia to that in Upper middle income?
Offer a terse response. 224.18. What is the difference between the highest and the second highest Coal rent(as % of GDP) in 1970?
Provide a short and direct response. 0.01. What is the difference between the highest and the second highest Coal rent(as % of GDP) of 1971?
Offer a terse response. 0.02. What is the difference between the highest and the second highest Coal rent(as % of GDP) of 1972?
Ensure brevity in your answer.  0.03. What is the difference between the highest and the second highest Coal rent(as % of GDP) of 1973?
Provide a short and direct response. 0.04. What is the difference between the highest and the lowest Coal rent(as % of GDP) of 1970?
Provide a succinct answer. 0.03. What is the difference between the highest and the lowest Coal rent(as % of GDP) in 1971?
Keep it short and to the point. 0.06. What is the difference between the highest and the lowest Coal rent(as % of GDP) of 1972?
Your answer should be compact. 0.08. What is the difference between the highest and the lowest Coal rent(as % of GDP) in 1973?
Provide a short and direct response. 0.1. 